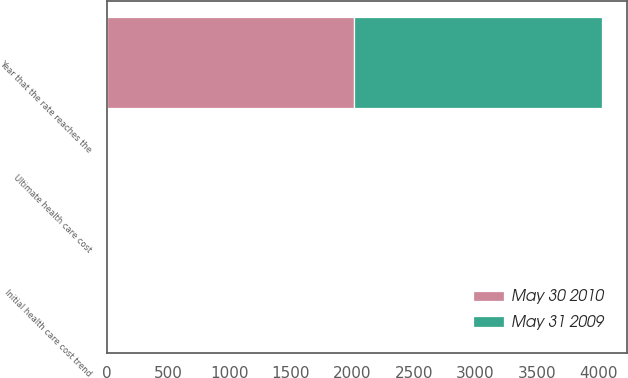Convert chart. <chart><loc_0><loc_0><loc_500><loc_500><stacked_bar_chart><ecel><fcel>Initial health care cost trend<fcel>Ultimate health care cost<fcel>Year that the rate reaches the<nl><fcel>May 31 2009<fcel>8<fcel>5<fcel>2016<nl><fcel>May 30 2010<fcel>8.5<fcel>5.5<fcel>2013<nl></chart> 